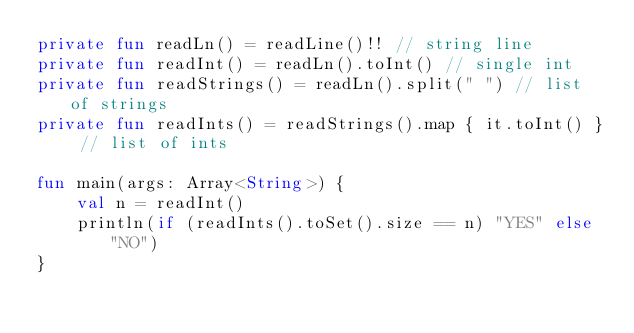Convert code to text. <code><loc_0><loc_0><loc_500><loc_500><_Kotlin_>private fun readLn() = readLine()!! // string line
private fun readInt() = readLn().toInt() // single int
private fun readStrings() = readLn().split(" ") // list of strings
private fun readInts() = readStrings().map { it.toInt() } // list of ints

fun main(args: Array<String>) {
    val n = readInt()
    println(if (readInts().toSet().size == n) "YES" else "NO")
}</code> 